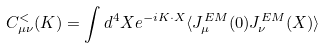<formula> <loc_0><loc_0><loc_500><loc_500>C _ { \mu \nu } ^ { < } ( K ) = \int d ^ { 4 } X e ^ { - i K \cdot X } \langle J _ { \mu } ^ { E M } ( 0 ) J _ { \nu } ^ { E M } ( X ) \rangle</formula> 